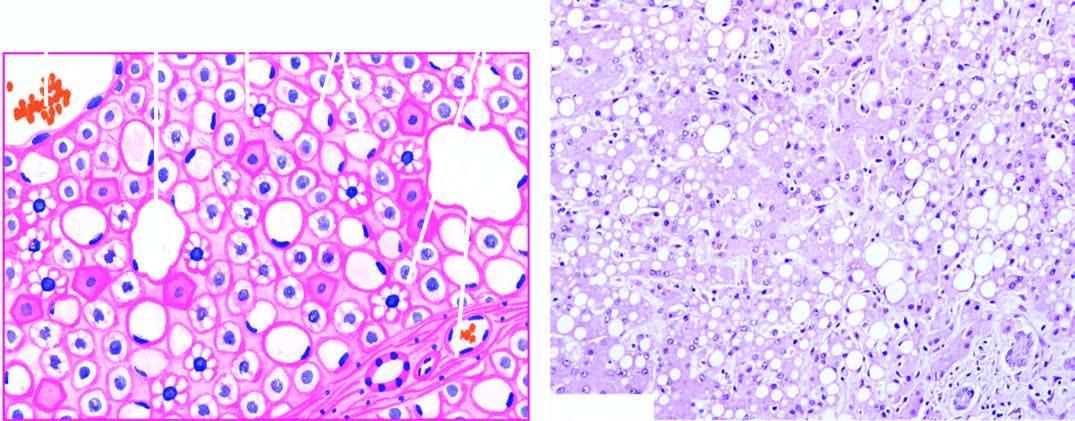what are distended with large lipid vacuoles with peripherally displaced nuclei?
Answer the question using a single word or phrase. Most of the hepatocytes 